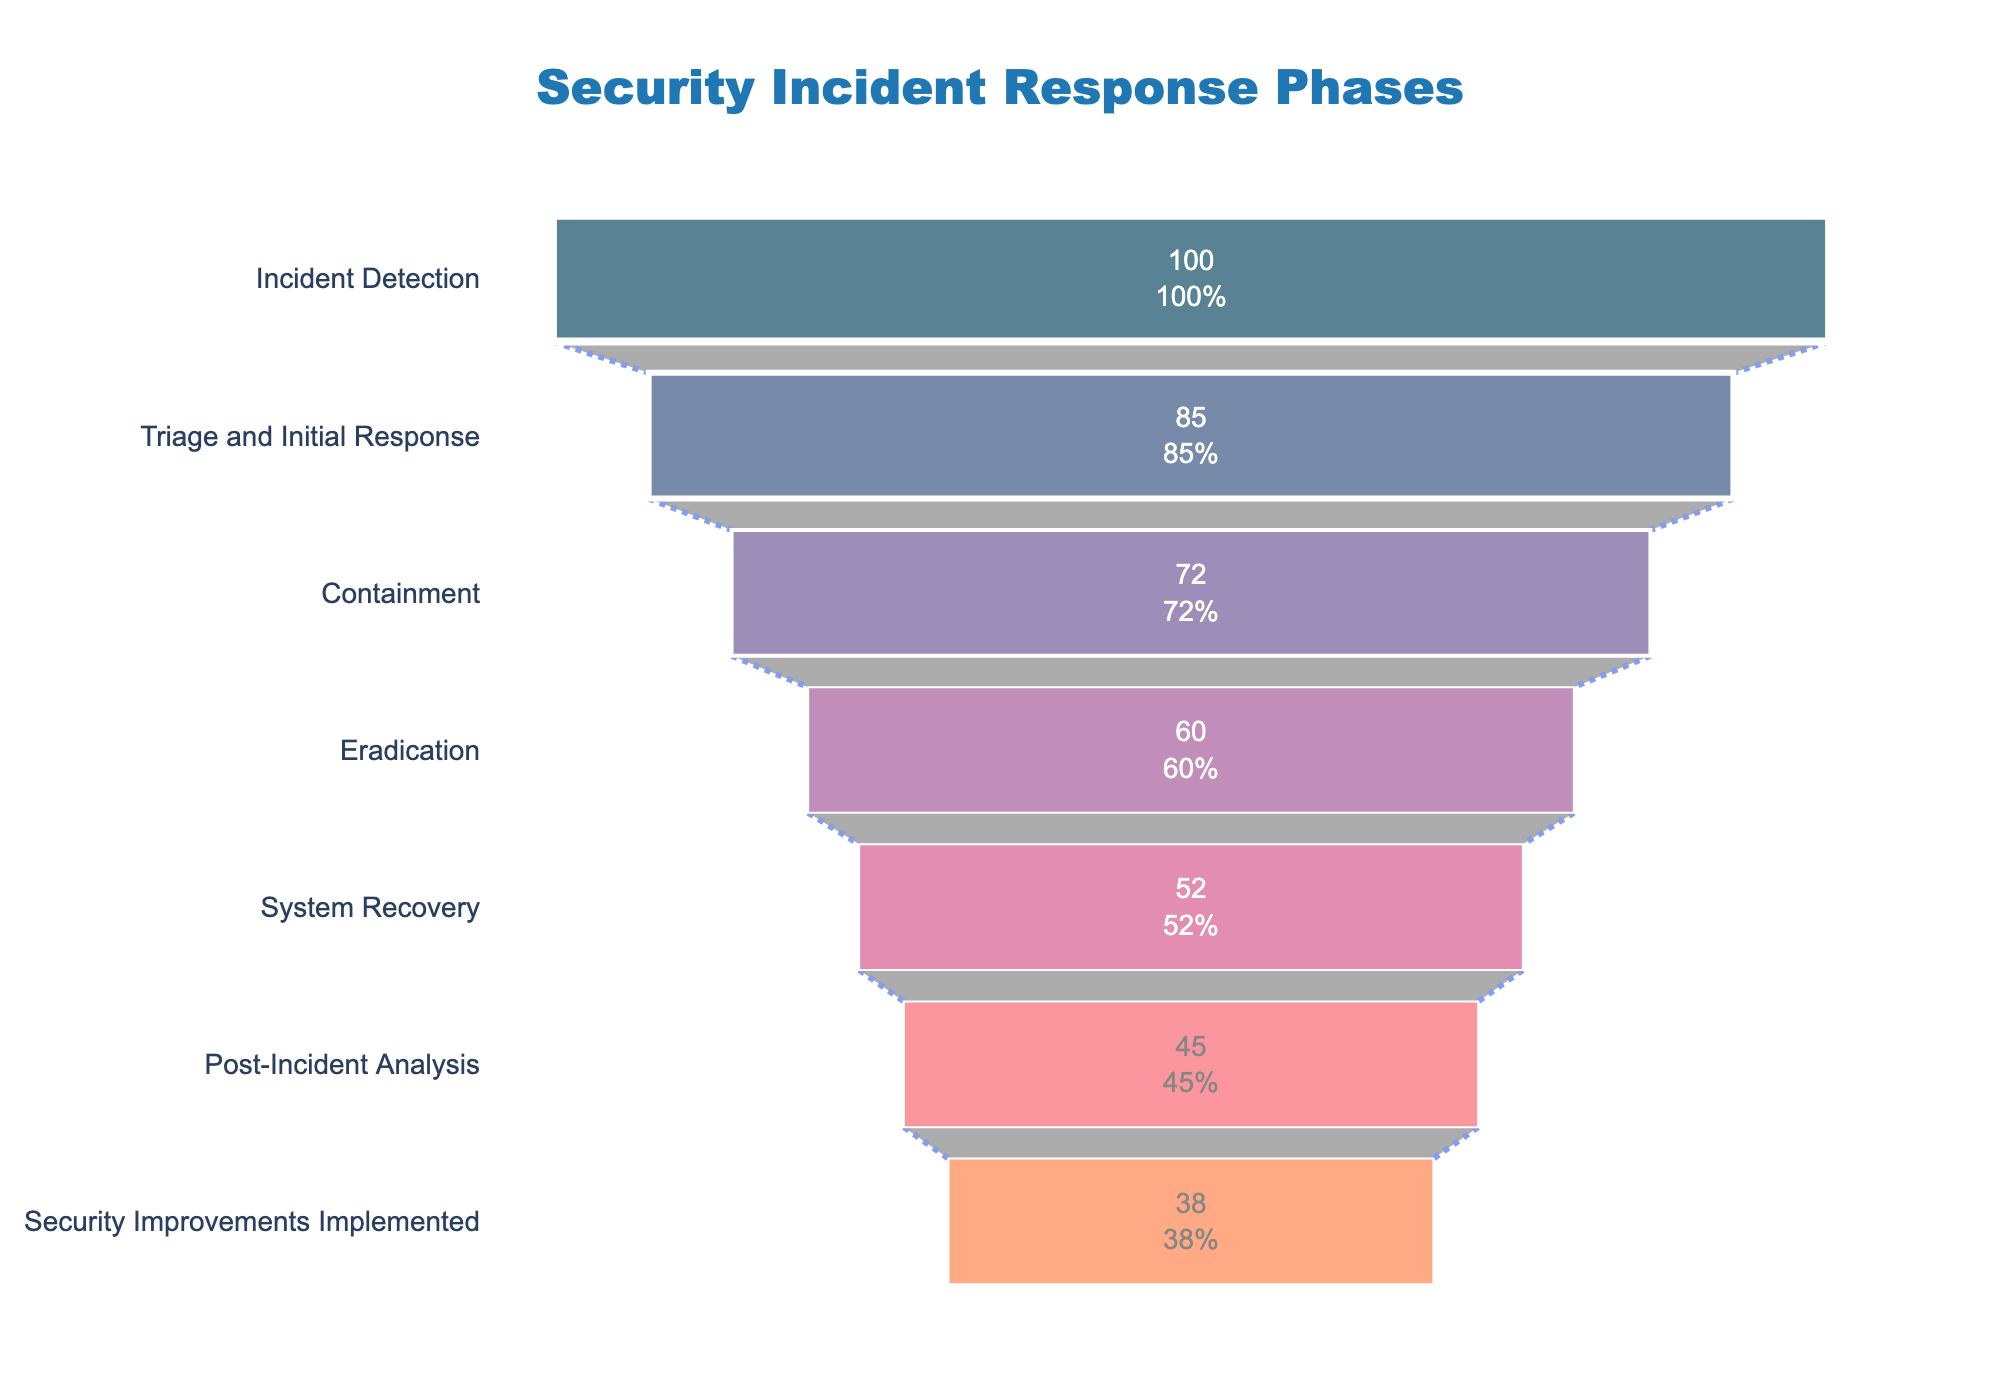What's the title of the figure? The title is usually placed at the top of the figure and is styled distinctively. The large blue text at the top center says "Security Incident Response Phases".
Answer: Security Incident Response Phases Which phase has the highest percentage of successful resolutions? The highest percentage of successful resolutions is shown by the largest segment at the top of the funnel chart. In this chart, the top segment corresponds to the "Incident Detection" phase with a 100% successful resolution rate.
Answer: Incident Detection What is the percentage decrease from the "Triage and Initial Response" phase to the "Containment" phase? The percentage for "Triage and Initial Response" is 85%, and for "Containment" it is 72%. The decrease is calculated as 85% - 72% = 13%.
Answer: 13% Which phase has the lowest percentage of successful resolutions? The smallest segment at the bottom of the funnel chart represents the lowest percentage. In this chart, the "Security Improvements Implemented" phase has a 38% successful resolution rate.
Answer: Security Improvements Implemented How many phases are shown in the funnel chart? By counting the number of segments along the y-axis labeled "Phase", we determine the count of distinct phases. There are 7 phases shown.
Answer: 7 What is the percentage of successful resolutions for the "System Recovery" phase? The percentage value for each phase is written inside its corresponding segment. For the "System Recovery" phase, this value is 52%.
Answer: 52% How much of a percentage drop is there between the "Containment" phase and the "System Recovery" phase? The "Containment" phase has a percentage of 72% and the "System Recovery" phase has 52%. The difference is 72% - 52% = 20%.
Answer: 20% Compare the percentage of the "Eradication" phase and the "Post-Incident Analysis" phase. Which one has a higher percentage and by how much? The percentage for the "Eradication" phase is 60%, and for the "Post-Incident Analysis" phase it is 45%. The "Eradication" phase is higher by 60% - 45% = 15%.
Answer: The Eradication phase is higher by 15% What percentage of phases achieved a successful resolution rate of over 70%? We need to count the number of phases with a successful resolution percentage greater than 70%. According to the data, two phases meet these criteria: "Incident Detection" (100%) and "Triage and Initial Response" (85%), which accounts for 2 out of 7 phases. The percentage is (2/7) * 100 ≈ 28.57%.
Answer: Approximately 28.57% What is the combined percentage of successful resolutions for the first and the last phases in the chart? The first phase ("Incident Detection") has 100% and the last phase ("Security Improvements Implemented") has 38%. Their combined percentage is 100% + 38% = 138%.
Answer: 138% 